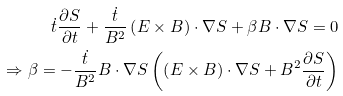<formula> <loc_0><loc_0><loc_500><loc_500>\dot { t } \frac { \partial S } { \partial t } + \frac { \dot { t } } { B ^ { 2 } } \left ( { E } \times { B } \right ) \cdot \nabla S + \beta { B } \cdot \nabla S = 0 \\ \Rightarrow \beta = - \frac { \dot { t } } { B ^ { 2 } } { B } \cdot \nabla S \left ( \left ( { E } \times { B } \right ) \cdot \nabla S + B ^ { 2 } \frac { \partial S } { \partial t } \right )</formula> 